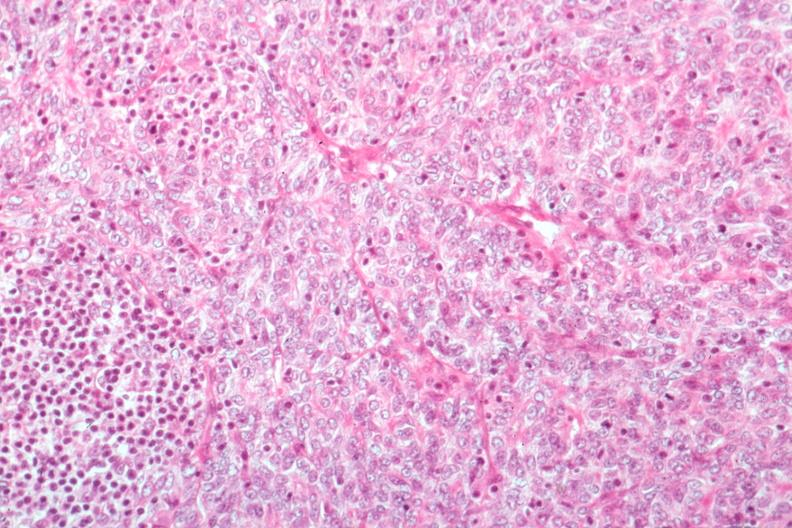what is present?
Answer the question using a single word or phrase. Thymoma 